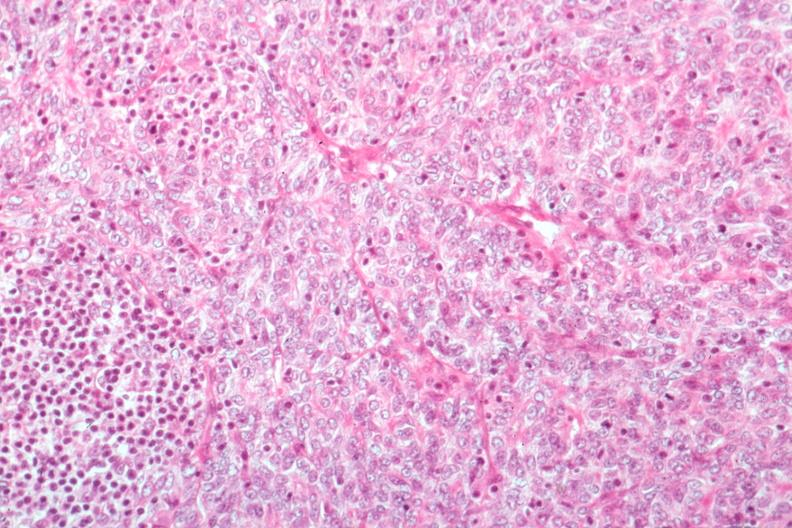what is present?
Answer the question using a single word or phrase. Thymoma 